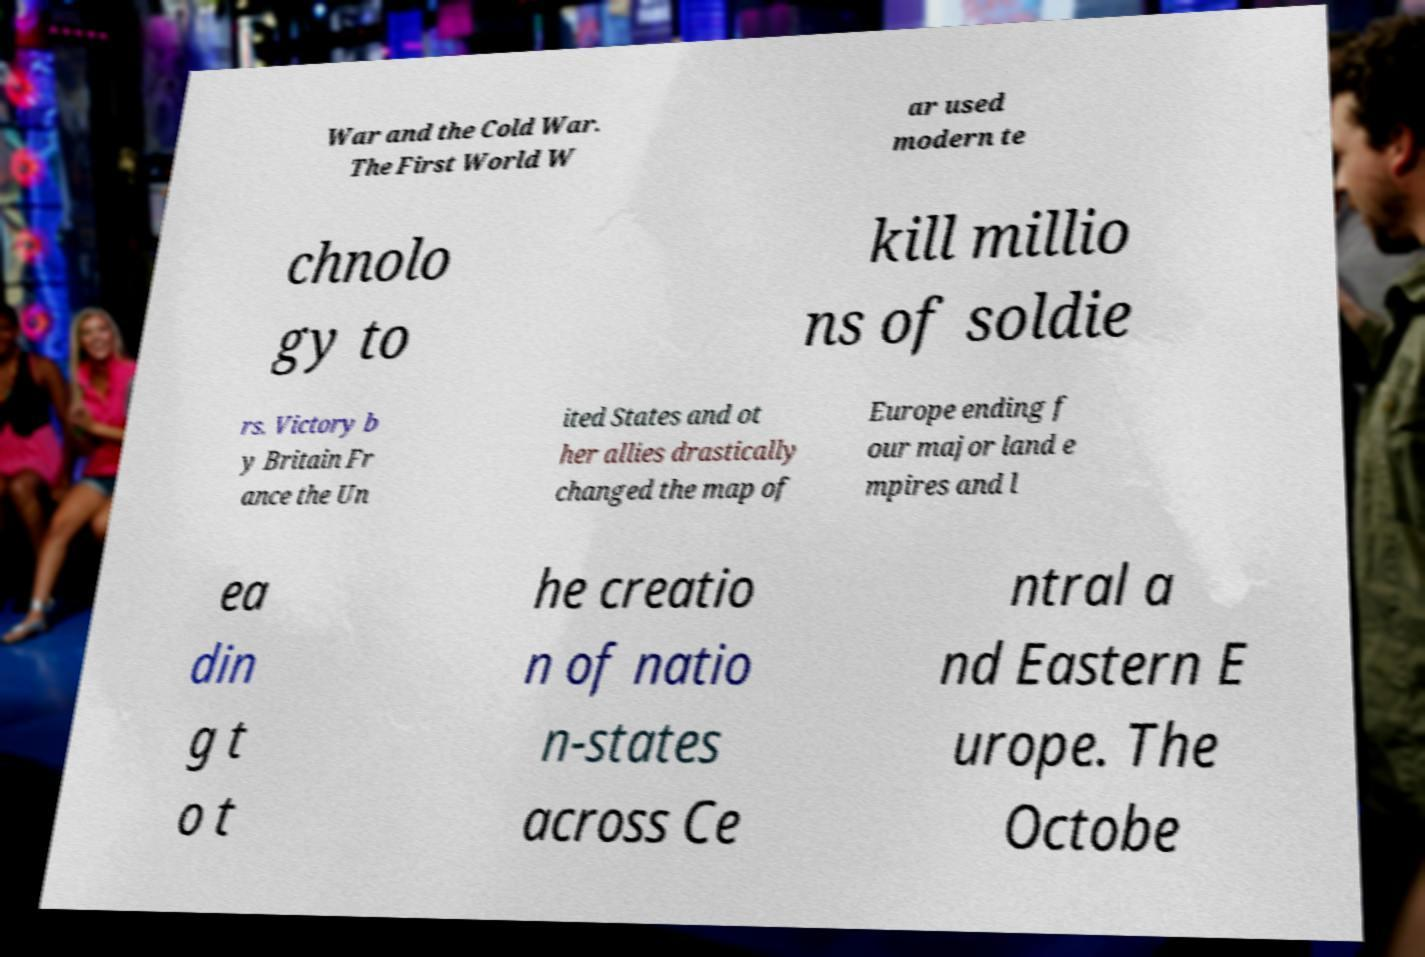Please identify and transcribe the text found in this image. War and the Cold War. The First World W ar used modern te chnolo gy to kill millio ns of soldie rs. Victory b y Britain Fr ance the Un ited States and ot her allies drastically changed the map of Europe ending f our major land e mpires and l ea din g t o t he creatio n of natio n-states across Ce ntral a nd Eastern E urope. The Octobe 